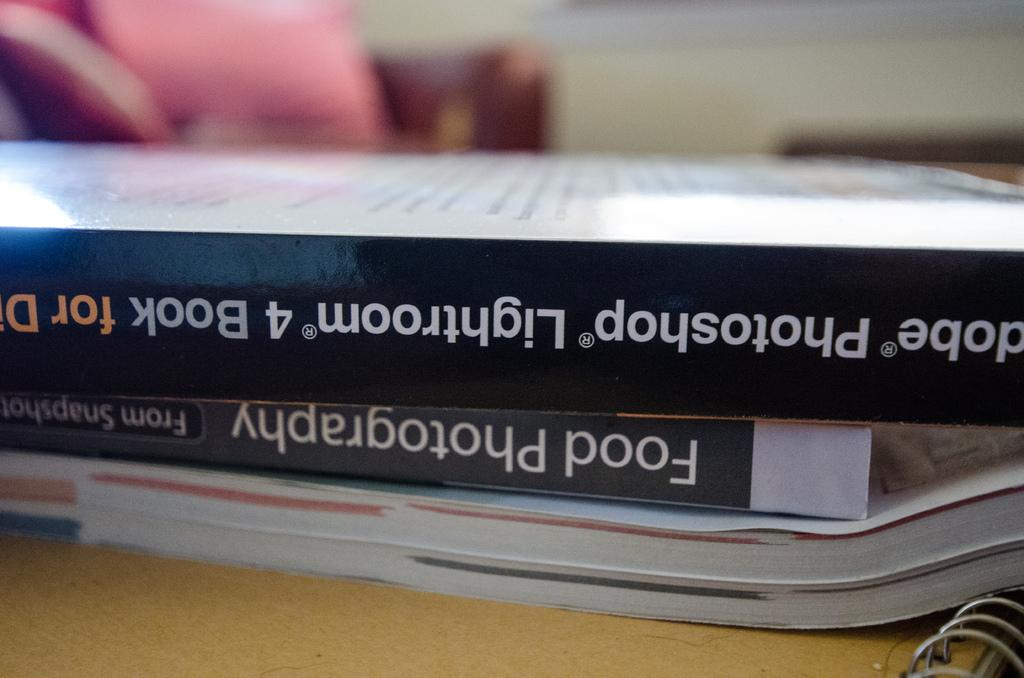What objects are present in the image? There are books in the image. What can be seen on the books? Something is written on the books. How does the transport system work in the image? There is no transport system present in the image; it only features books with writing on them. 